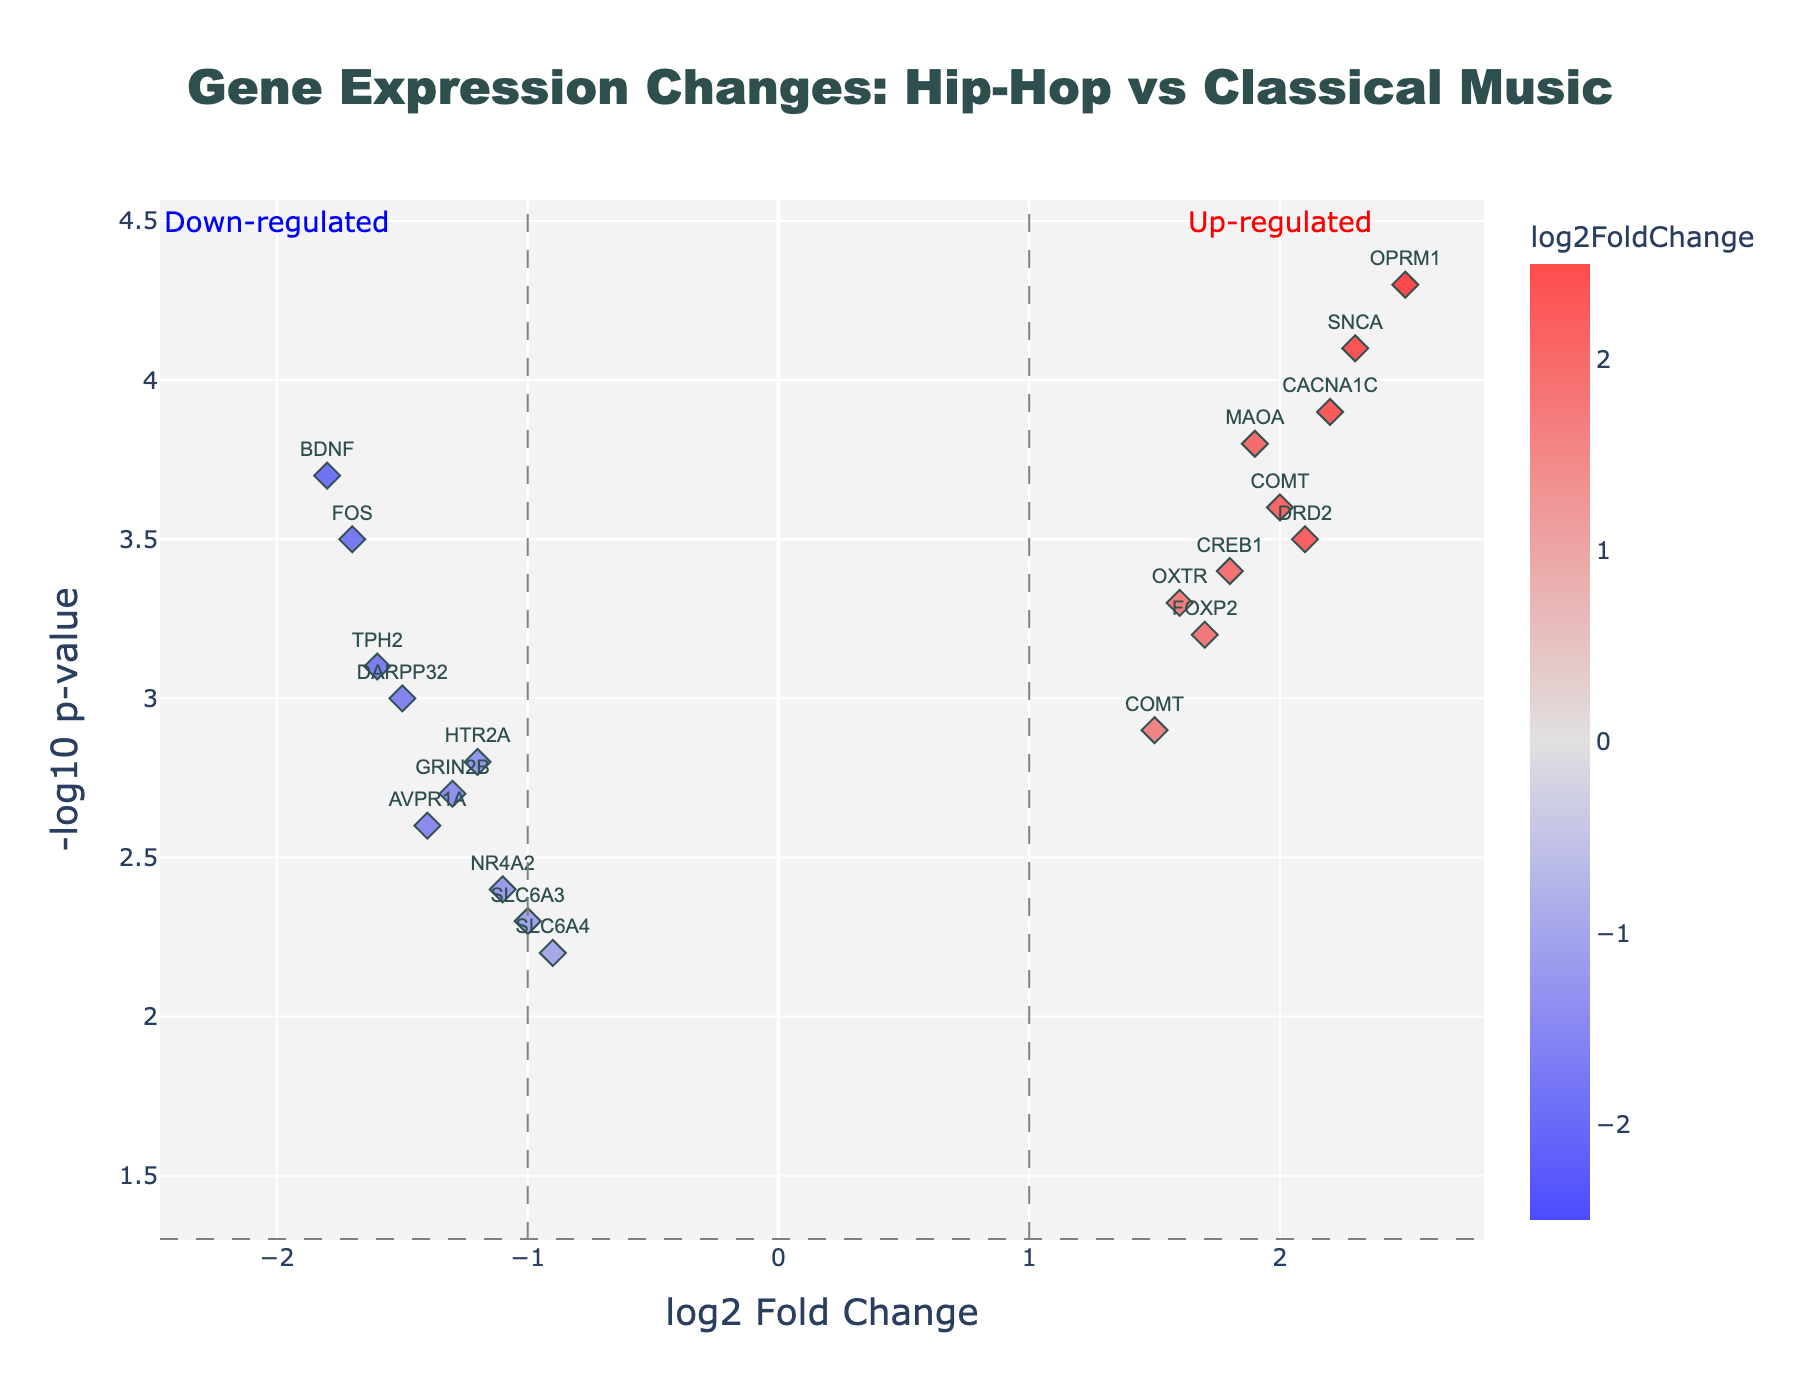What are the axes labels in the plot? The axes labels indicate the quantities being measured in the plot. The x-axis label is 'log2 Fold Change', which represents the log base 2 of the fold change in gene expression between hip-hop and classical music. The y-axis label is '-log10 p-value', which represents the negative log base 10 of the p-value, indicating the statistical significance of the fold change.
Answer: log2 Fold Change, -log10 p-value What is the significance threshold line on the y-axis? The significance threshold line on the y-axis is used to indicate the cutoff for statistical significance. It is usually set at -log10(0.05) because a p-value of 0.05 is a common threshold for significance. Therefore, the threshold line is at y = 1.3 (-log10(0.05)).
Answer: 1.3 How many genes are up-regulated with high statistical significance? Up-regulated genes with high statistical significance are those with log2FoldChange > 1 and neglog10PValue > 1.3. By inspecting the plot, you see the genes OPRM1, CACNA1C, SNCA, MAOA, DRD2, CREB1, FOXP2, and COMT fall into this category.
Answer: 8 Which gene has the highest log2 fold change? To find the gene with the highest log2 fold change, you look for the point farthest to the right on the x-axis. The gene OPRM1 has the highest log2 fold change value of 2.5 according to the data.
Answer: OPRM1 How does the gene BDNF compare to SNCA in terms of fold change and significance? Comparing BDNF and SNCA involves looking at both their fold changes and p-values. SNCA has a log2FoldChange of 2.3 and a neglog10PValue of 4.1, indicating it is up-regulated with high significance. BDNF has a log2FoldChange of -1.8 and a neglog10PValue of 3.7, indicating it is down-regulated with high significance. So, SNCA is up-regulated and more significant than BDNF.
Answer: SNCA is up-regulated and more significant Which gene shows the highest significance regardless of fold change? The highest significance is indicated by the highest y-value (neglog10PValue). The gene OPRM1 shows the highest significance with a neglog10PValue of 4.3.
Answer: OPRM1 Are there more up-regulated or down-regulated genes with significant changes? To determine this, count the genes with log2FoldChange > 1 or <-1 and neglog10PValue > 1.3. There are 8 up-regulated (log2FoldChange > 1) and 6 down-regulated (log2FoldChange < -1).
Answer: More up-regulated What does the annotation in the upper right quadrant represent? The annotation in the upper right quadrant reads "Up-regulated". This indicates that genes in this quadrant have positive log2 fold changes (up-regulated) and high statistical significance (high -log10 p-value).
Answer: Up-regulated genes Which genes fall into the "down-regulated" category with high statistical significance? Genes in the "down-regulated" category have log2FoldChange < -1 and neglog10PValue > 1.3. These genes include BDNF, TPH2, FOS, DARPP32, and AVPR1A.
Answer: BDNF, TPH2, FOS, DARPP32, AVPR1A 